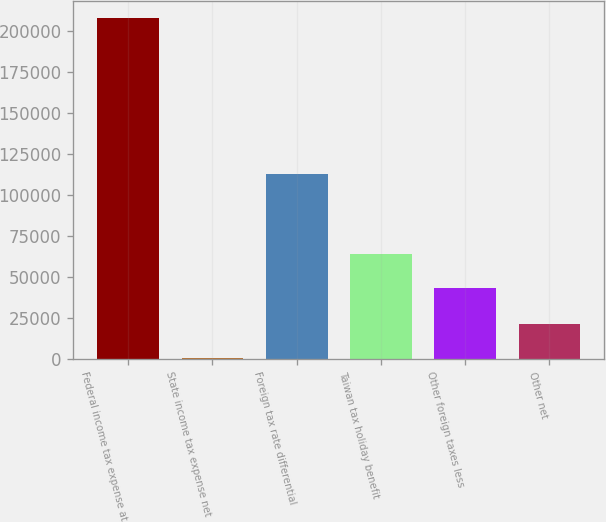<chart> <loc_0><loc_0><loc_500><loc_500><bar_chart><fcel>Federal income tax expense at<fcel>State income tax expense net<fcel>Foreign tax rate differential<fcel>Taiwan tax holiday benefit<fcel>Other foreign taxes less<fcel>Other net<nl><fcel>208094<fcel>658<fcel>112903<fcel>64188.6<fcel>43445<fcel>21401.6<nl></chart> 